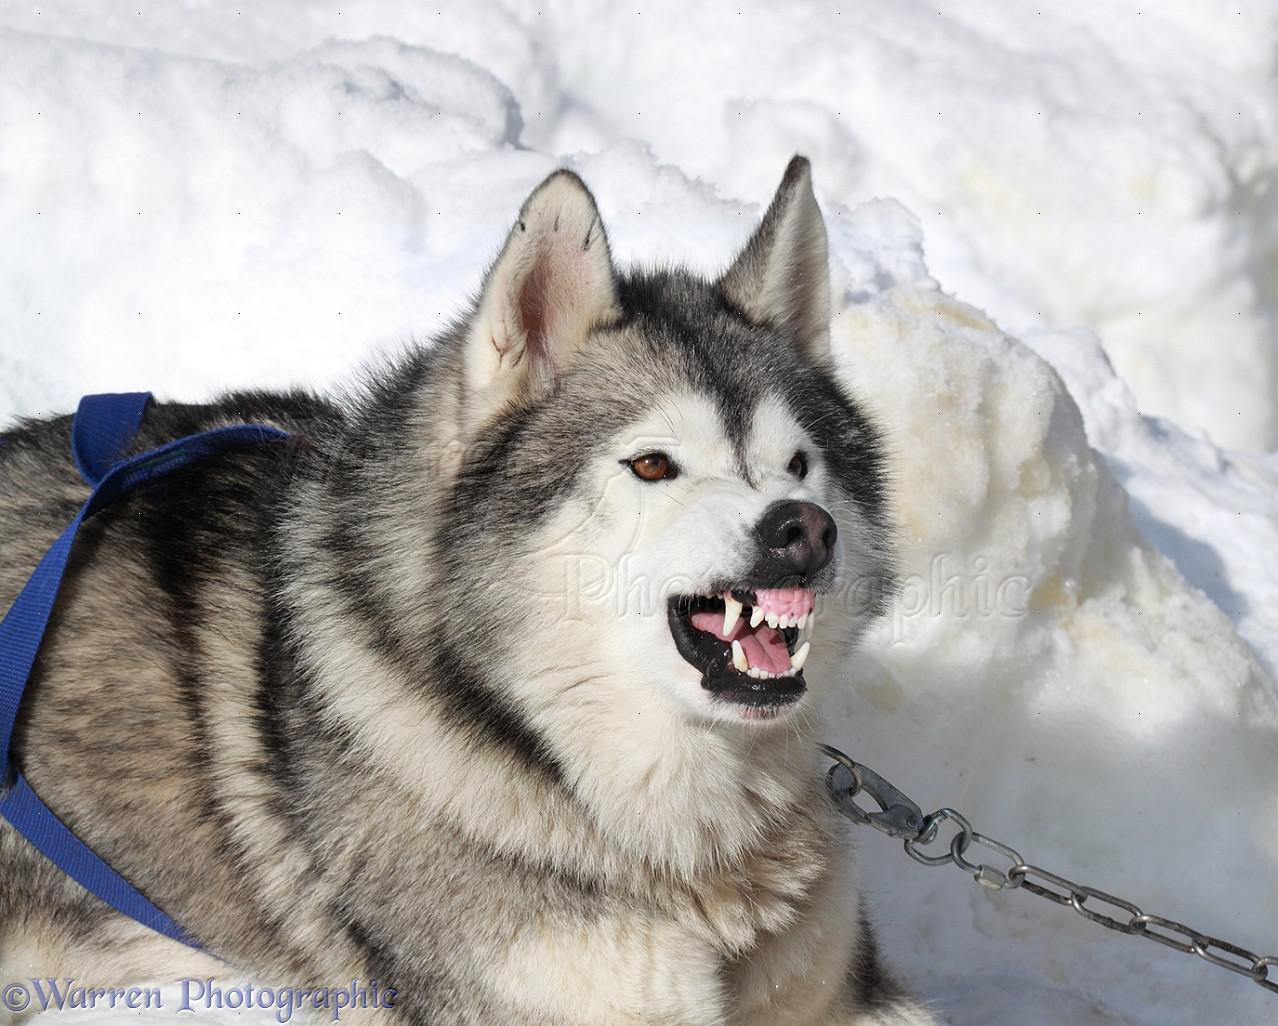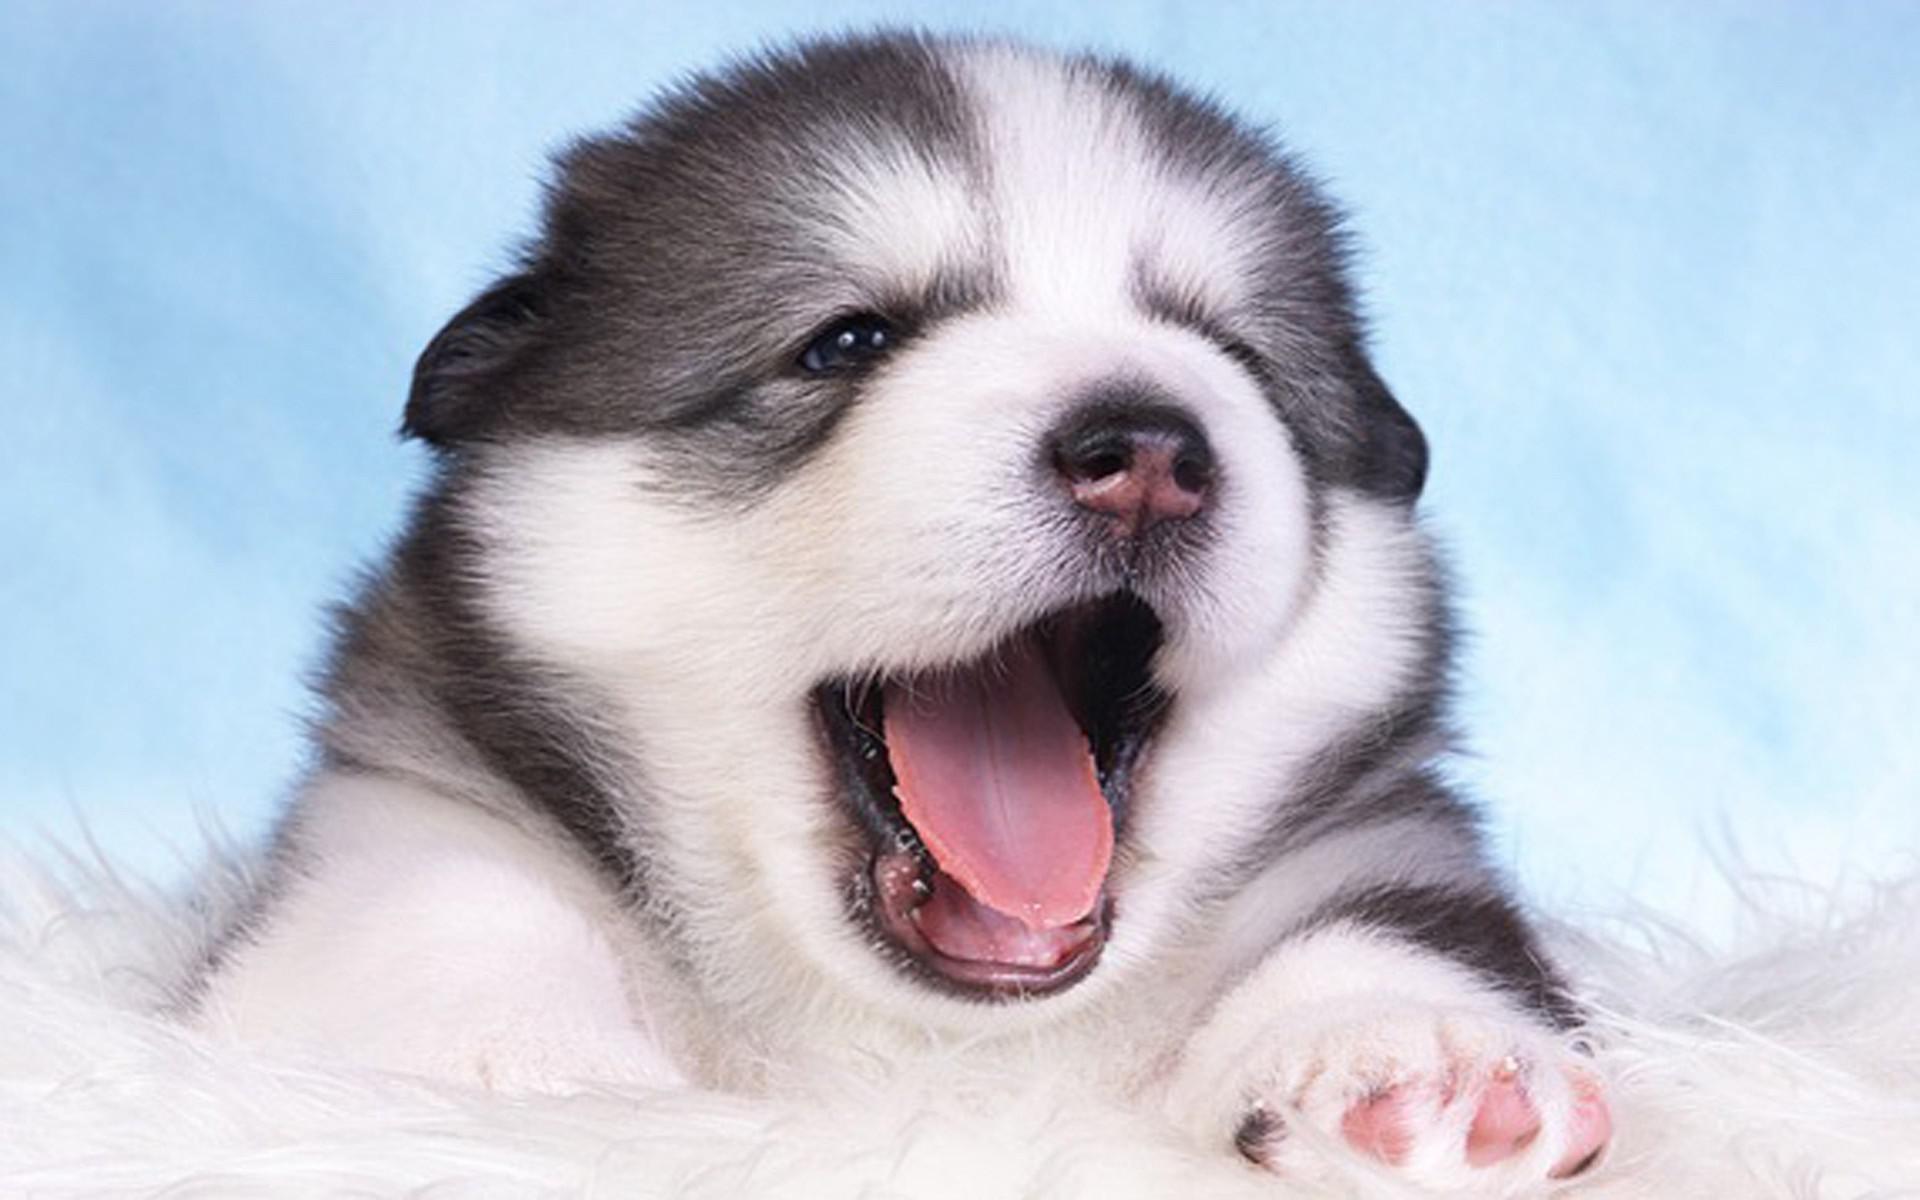The first image is the image on the left, the second image is the image on the right. Analyze the images presented: Is the assertion "There is a dog with its mouth open in each image." valid? Answer yes or no. Yes. The first image is the image on the left, the second image is the image on the right. Evaluate the accuracy of this statement regarding the images: "One husky has its mouth open but is not snarling, and a different husky wears something blue around itself and has upright ears.". Is it true? Answer yes or no. Yes. 